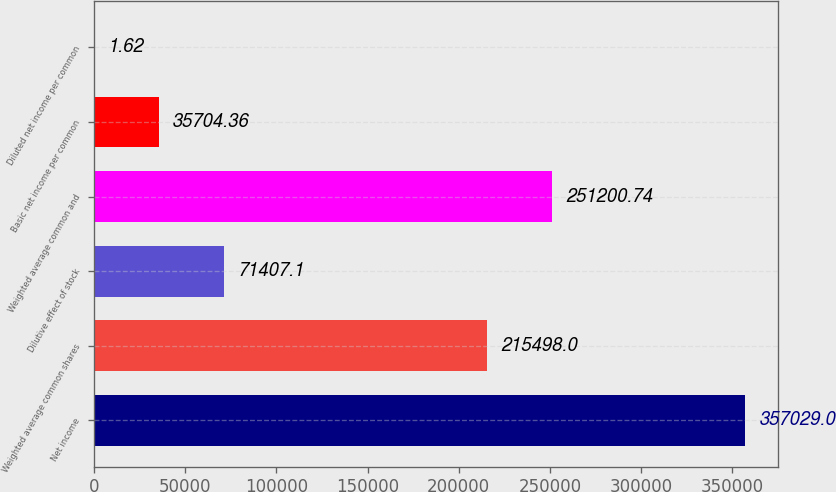Convert chart to OTSL. <chart><loc_0><loc_0><loc_500><loc_500><bar_chart><fcel>Net income<fcel>Weighted average common shares<fcel>Dilutive effect of stock<fcel>Weighted average common and<fcel>Basic net income per common<fcel>Diluted net income per common<nl><fcel>357029<fcel>215498<fcel>71407.1<fcel>251201<fcel>35704.4<fcel>1.62<nl></chart> 